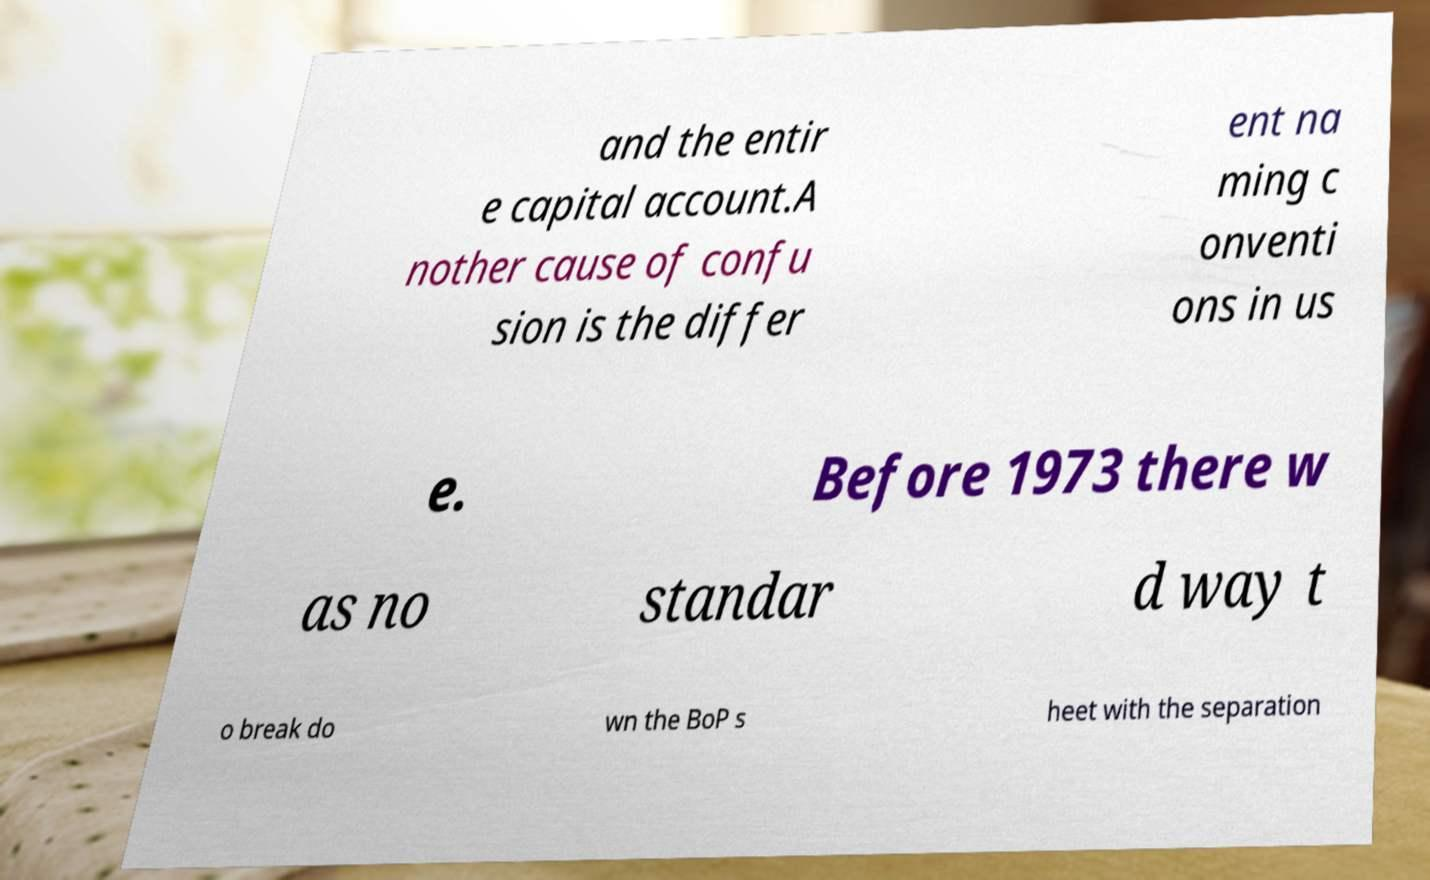Please read and relay the text visible in this image. What does it say? and the entir e capital account.A nother cause of confu sion is the differ ent na ming c onventi ons in us e. Before 1973 there w as no standar d way t o break do wn the BoP s heet with the separation 